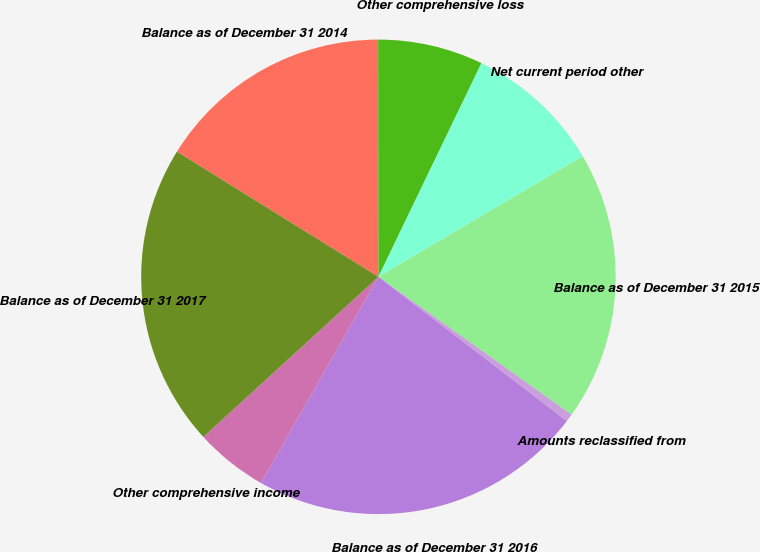Convert chart. <chart><loc_0><loc_0><loc_500><loc_500><pie_chart><fcel>Balance as of December 31 2014<fcel>Other comprehensive loss<fcel>Net current period other<fcel>Balance as of December 31 2015<fcel>Amounts reclassified from<fcel>Balance as of December 31 2016<fcel>Other comprehensive income<fcel>Balance as of December 31 2017<nl><fcel>16.13%<fcel>7.17%<fcel>9.37%<fcel>18.34%<fcel>0.54%<fcel>22.85%<fcel>4.96%<fcel>20.64%<nl></chart> 